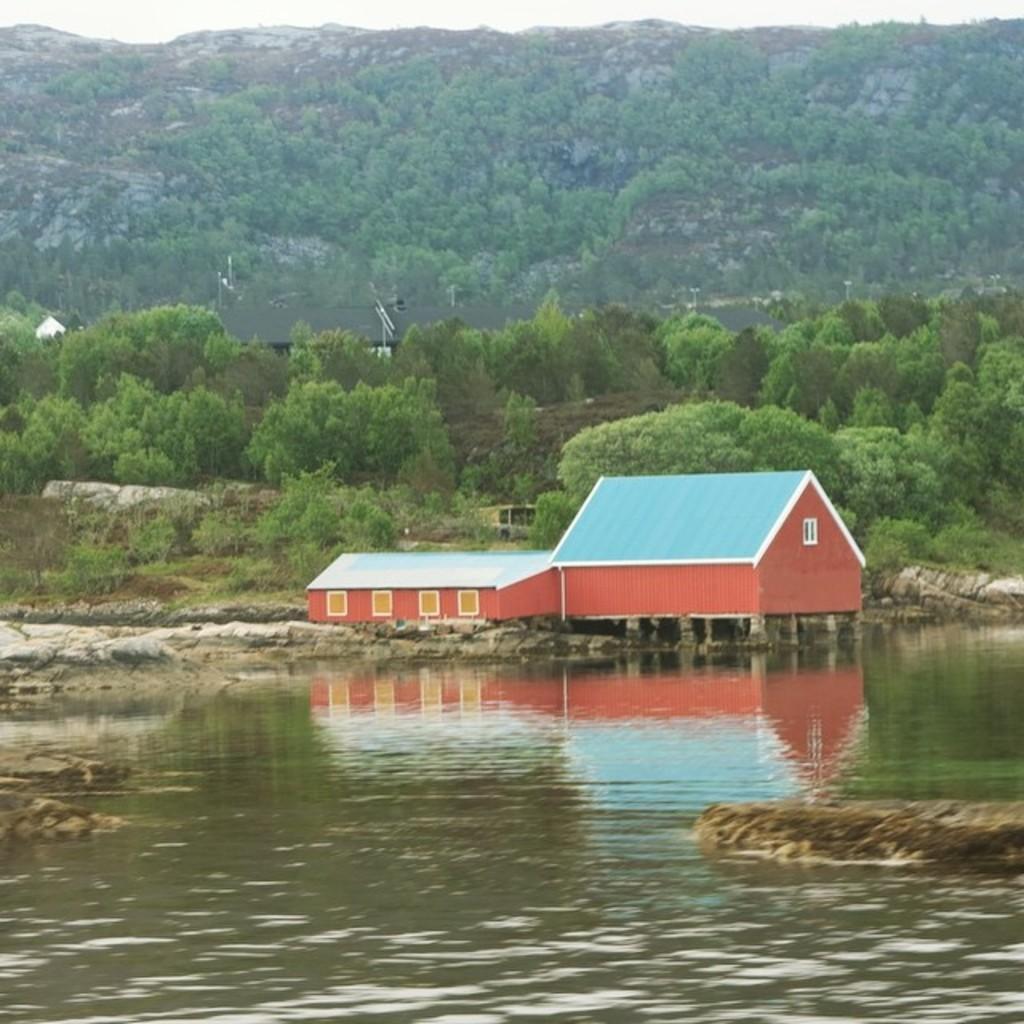Can you describe this image briefly? In this image there is water, behind the water, there is a house, behind the house there are trees and mountains. 